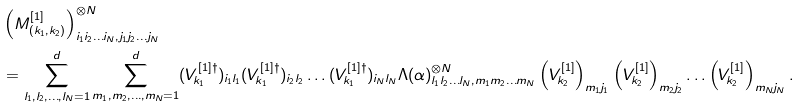Convert formula to latex. <formula><loc_0><loc_0><loc_500><loc_500>& \left ( M _ { ( k _ { 1 } , k _ { 2 } ) } ^ { [ 1 ] } \right ) _ { i _ { 1 } i _ { 2 } \dots i _ { N } , j _ { 1 } j _ { 2 } \dots j _ { N } } ^ { \otimes N } \\ & = \sum _ { l _ { 1 } , l _ { 2 } , \dots , l _ { N } = 1 } ^ { d } \sum _ { m _ { 1 } , m _ { 2 } , \dots , m _ { N } = 1 } ^ { d } ( V _ { k _ { 1 } } ^ { [ 1 ] \dagger } ) _ { i _ { 1 } l _ { 1 } } ( V _ { k _ { 1 } } ^ { [ 1 ] \dagger } ) _ { i _ { 2 } l _ { 2 } } \dots ( V _ { k _ { 1 } } ^ { [ 1 ] \dagger } ) _ { i _ { N } l _ { N } } \Lambda ( \alpha ) _ { l _ { 1 } l _ { 2 } \dots l _ { N } , m _ { 1 } m _ { 2 } \dots m _ { N } } ^ { \otimes N } \left ( V _ { k _ { 2 } } ^ { [ 1 ] } \right ) _ { m _ { 1 } j _ { 1 } } \left ( V _ { k _ { 2 } } ^ { [ 1 ] } \right ) _ { m _ { 2 } j _ { 2 } } \dots \left ( V _ { k _ { 2 } } ^ { [ 1 ] } \right ) _ { m _ { N } j _ { N } } .</formula> 